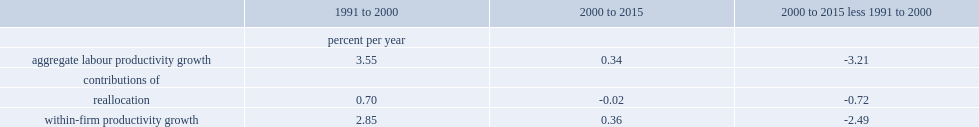What was the percent per year of the improved reallocation at the three-digit naics level contributed to aggregate labour productivity growth for the period of 1991 to 2000? 0.7. What was the percent per year of the improved reallocation at the three-digit naics level contributed to aggregate labour productivity growth for the period of 1991 to 2000? 0.7. 